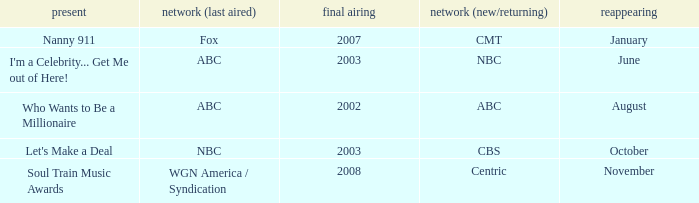When did soul train music awards return? November. 